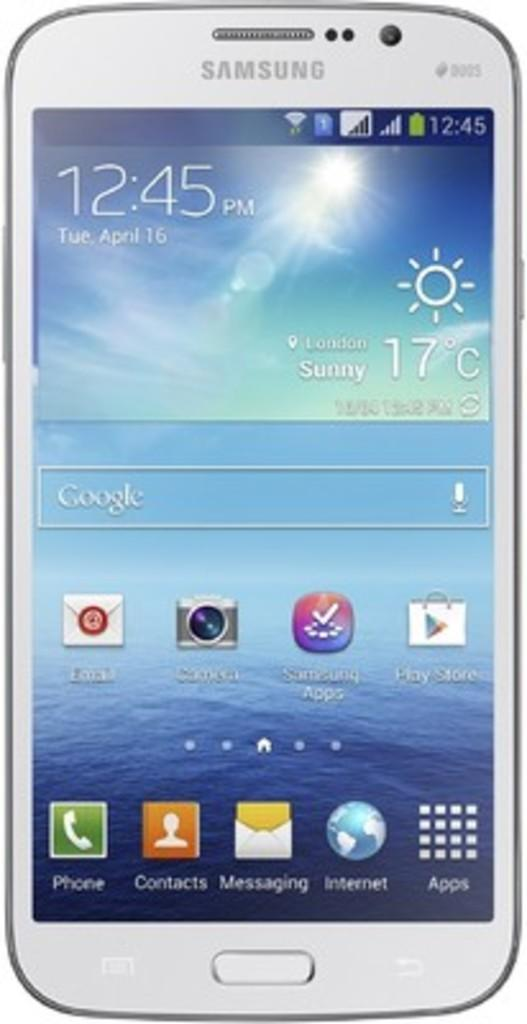<image>
Write a terse but informative summary of the picture. Samsung phone with the home screen showing the apps and time 